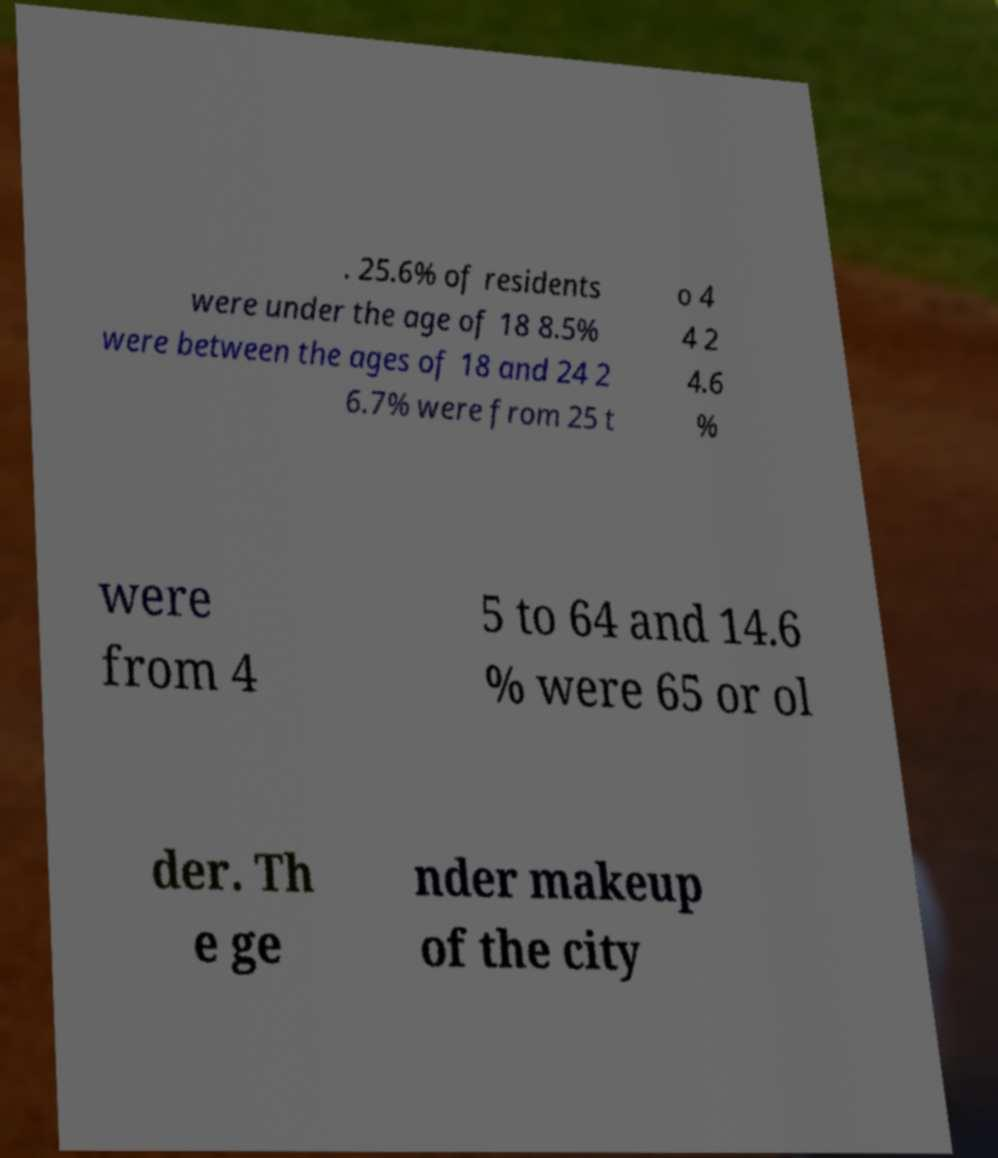What messages or text are displayed in this image? I need them in a readable, typed format. . 25.6% of residents were under the age of 18 8.5% were between the ages of 18 and 24 2 6.7% were from 25 t o 4 4 2 4.6 % were from 4 5 to 64 and 14.6 % were 65 or ol der. Th e ge nder makeup of the city 